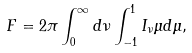<formula> <loc_0><loc_0><loc_500><loc_500>F = 2 \pi \int _ { 0 } ^ { \infty } d \nu \int _ { - 1 } ^ { 1 } I _ { \nu } \mu d \mu ,</formula> 